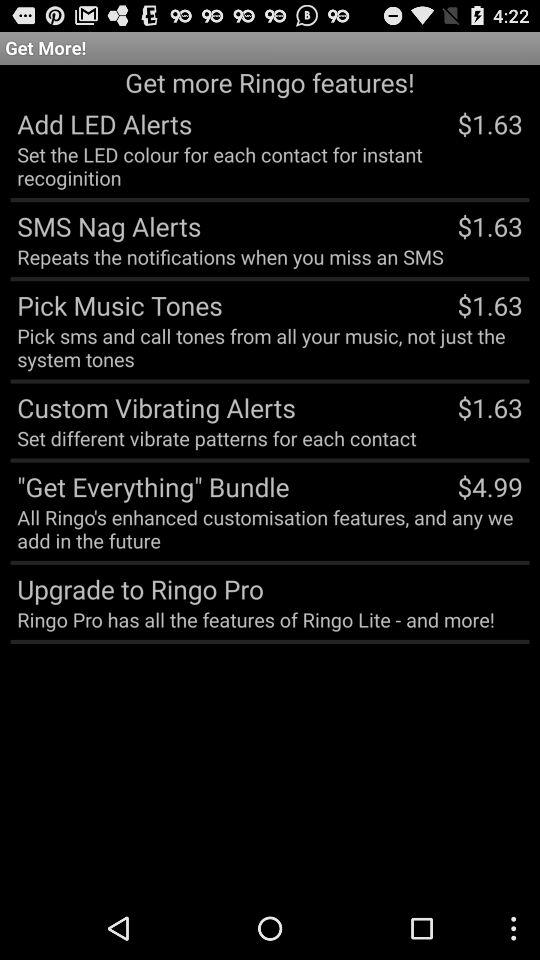What is the price of "Pick Music Tones"? The price is $1.63. 